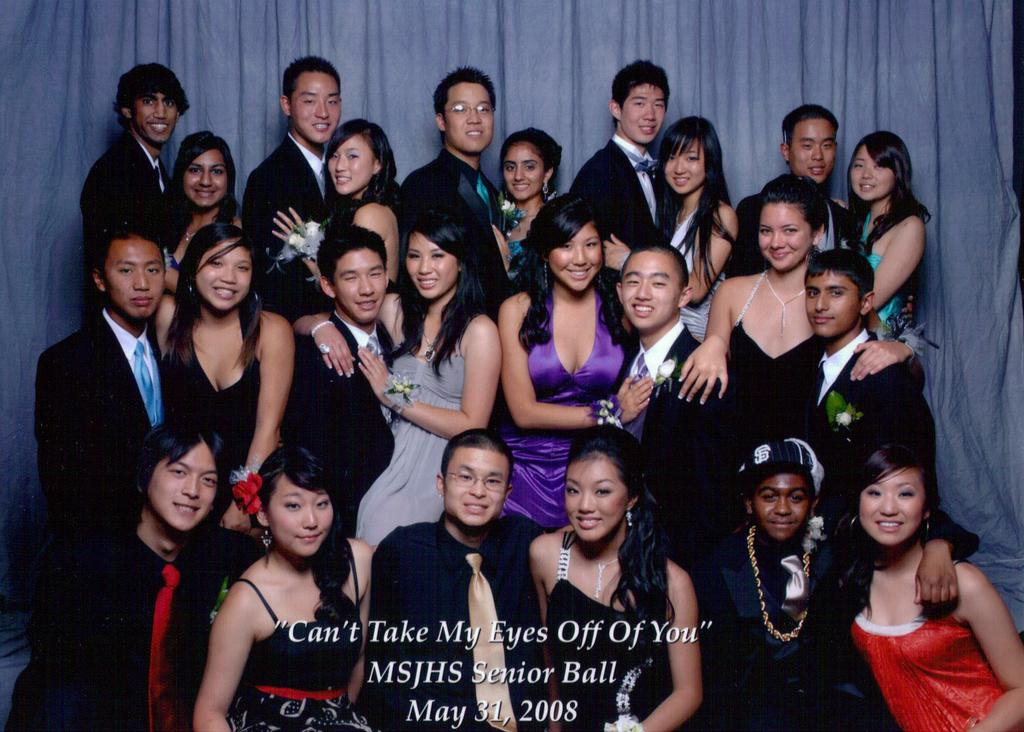How many people are in the image? There is a group of people in the image. What can be observed about the clothing of the people in the image? The people are wearing different color dresses. What color is the curtain visible in the background? There is a blue curtain visible in the background. Can you describe what is written on the curtain? Unfortunately, the specific text on the curtain cannot be determined from the image. How many trains can be seen in the image? There are no trains present in the image. What type of chair is being used by the people in the image? There is no chair visible in the image; it only shows a group of people wearing different color dresses and a blue curtain in the background. 